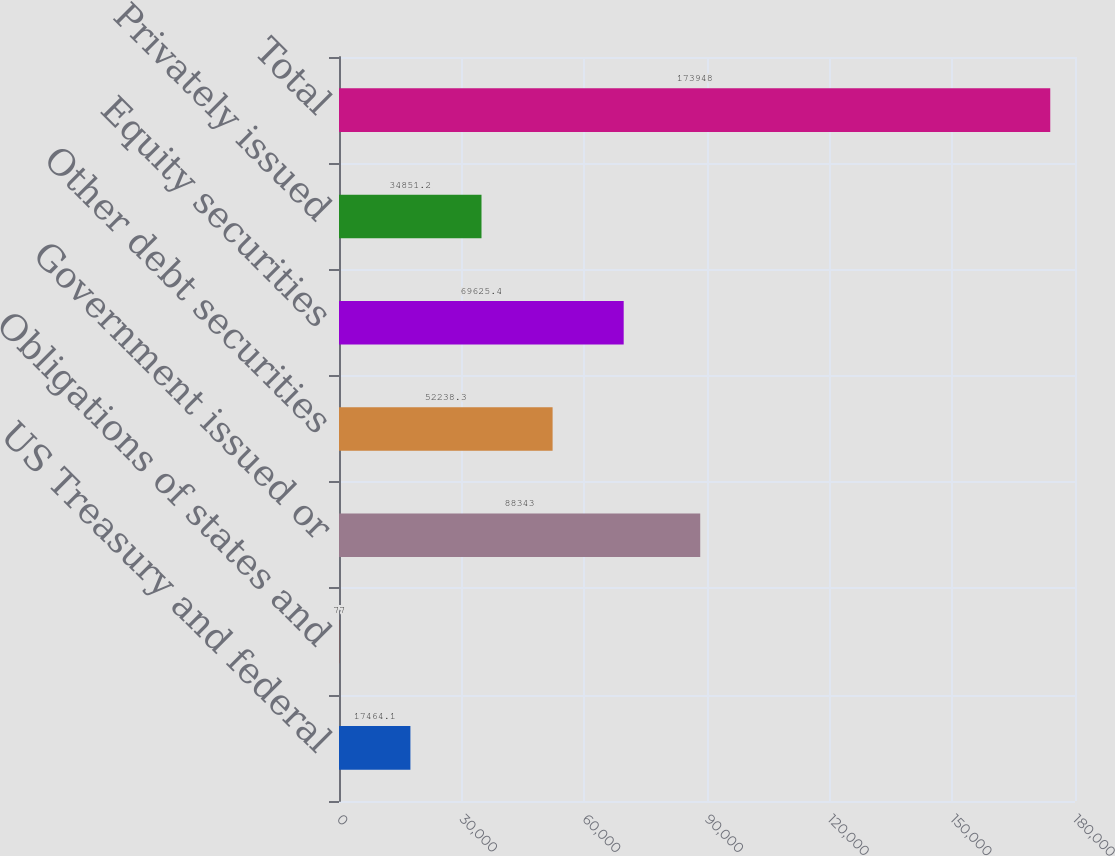Convert chart. <chart><loc_0><loc_0><loc_500><loc_500><bar_chart><fcel>US Treasury and federal<fcel>Obligations of states and<fcel>Government issued or<fcel>Other debt securities<fcel>Equity securities<fcel>Privately issued<fcel>Total<nl><fcel>17464.1<fcel>77<fcel>88343<fcel>52238.3<fcel>69625.4<fcel>34851.2<fcel>173948<nl></chart> 